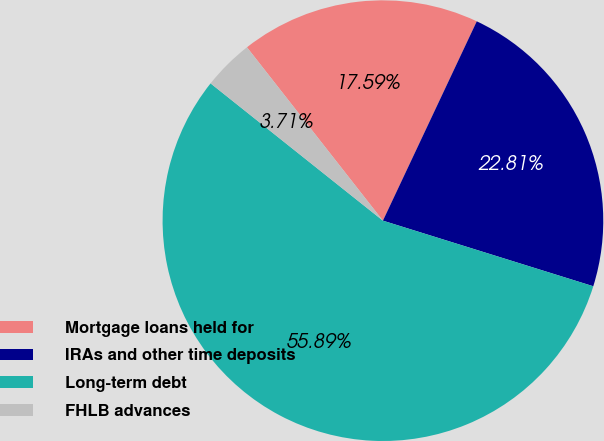Convert chart to OTSL. <chart><loc_0><loc_0><loc_500><loc_500><pie_chart><fcel>Mortgage loans held for<fcel>IRAs and other time deposits<fcel>Long-term debt<fcel>FHLB advances<nl><fcel>17.59%<fcel>22.81%<fcel>55.9%<fcel>3.71%<nl></chart> 